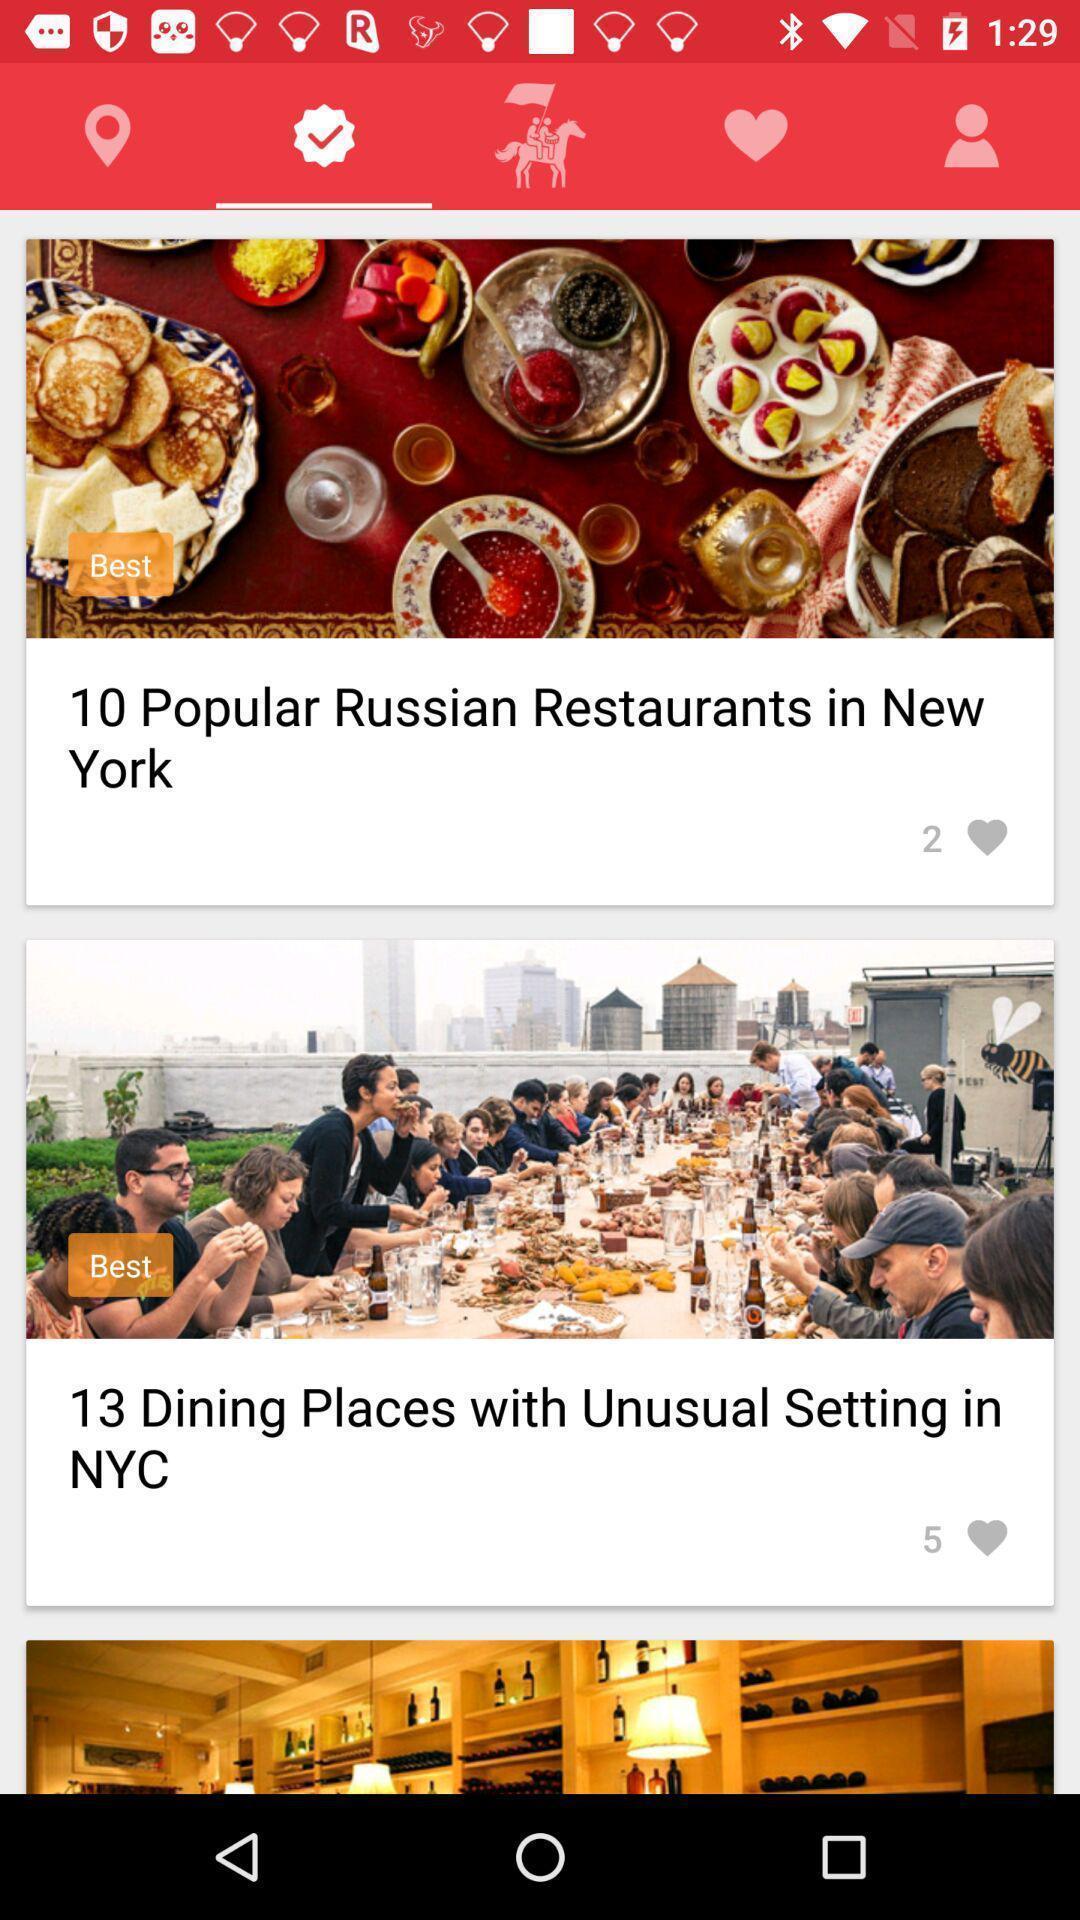Please provide a description for this image. Page showing the categories in restaurant app. 